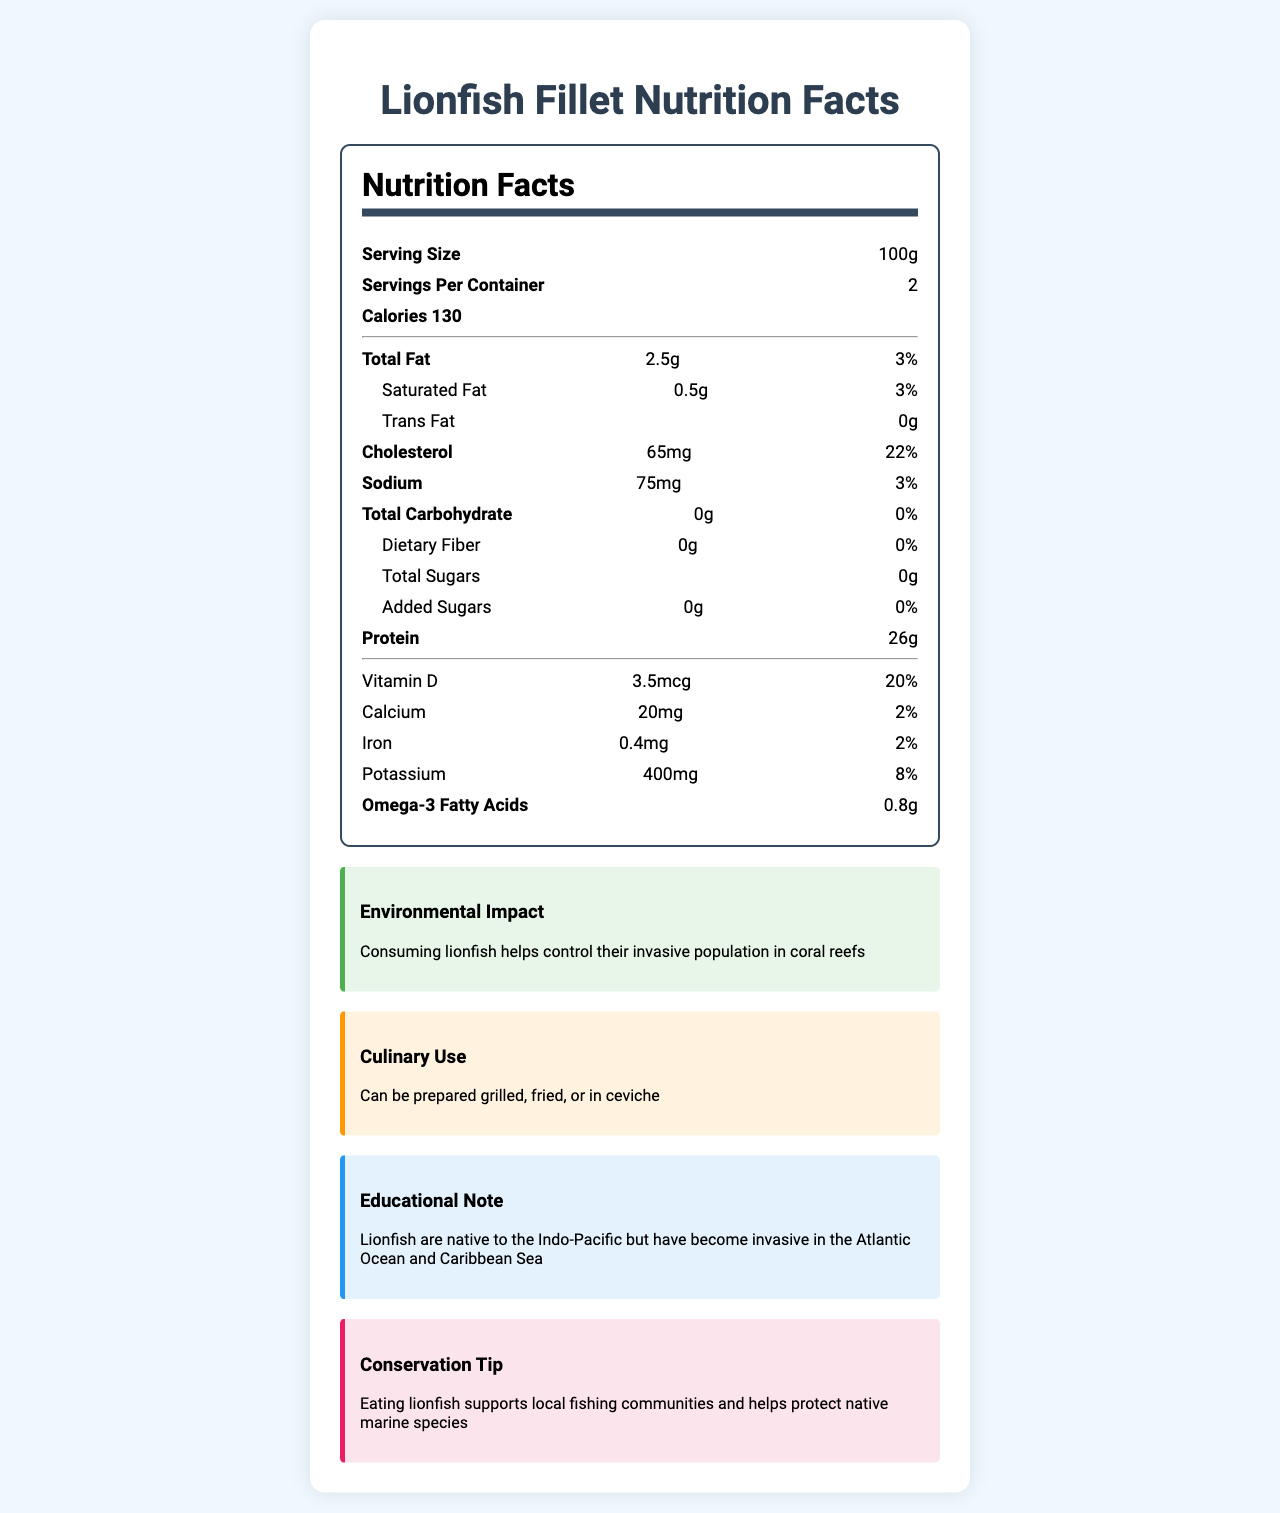what is the serving size of Lionfish Fillet? The serving size is explicitly mentioned as 100g in the document.
Answer: 100g how many calories are there per serving? The document states that there are 130 calories per serving.
Answer: 130 what is the amount of saturated fat per serving? The document specifies that each serving contains 0.5g of saturated fat.
Answer: 0.5g Does the Lionfish Fillet contain any trans fats? The document clearly states that there are 0g trans fats.
Answer: No how much protein is in a serving? Each serving contains 26g of protein as per the document.
Answer: 26g what percentage of the Daily Value of Vitamin D is provided per serving? A. 3% B. 20% C. 8% D. 15% The document specifies that each serving provides 20% of the Daily Value of Vitamin D.
Answer: B which nutrient is provided the least amount when compared to its Daily Value? A. Calcium B. Iron C. Vitamin D Iron is provided at 2% of the Daily Value, which is the lowest percentage compared to Calcium (2%) and Vitamin D (20%).
Answer: B Is eating Lionfish beneficial for the environment? The document notes that consuming lionfish helps control their invasive population in coral reefs.
Answer: Yes what culinary uses are recommended for Lionfish Fillet? The document mentions that Lionfish Fillet can be prepared grilled, fried, or in ceviche.
Answer: Grilled, fried, or in ceviche Summarize the main idea of the document. The document is structured with a nutrition facts section detailing calories, fats, cholesterol, sodium, carbohydrates, and other nutrients per serving. Additionally, it explains the positive environmental impact of consuming lionfish, suggests culinary uses, provides an educational note on its invasiveness, and offers a conservation tip promoting support for local fishing communities.
Answer: The Nutrition Facts Label for Lionfish Fillet provides detailed nutritional information, highlights its environmental benefits in controlling invasive species, suggests culinary uses, and notes its educational and conservation significance. what are the omega-3 fatty acid contents in Lionfish Fillet? The document specifies that each serving contains 0.8g of omega-3 fatty acids.
Answer: 0.8g why is eating lionfish beneficial for local fishing communities? This information is provided in the "conservation tip" section of the document.
Answer: Eating lionfish supports local fishing communities and helps protect native marine species. how many servings are there per container of Lionfish Fillet? The document specifies that there are 2 servings per container.
Answer: 2 how much cholesterol is in a serving of Lionfish Fillet? The document states that each serving contains 65mg of cholesterol.
Answer: 65mg cannot be determined from this document? The document does not provide information on whether the Lionfish Fillet is organic. This information is not addressed in the document.
Answer: Is Lionfish Fillet organic? 